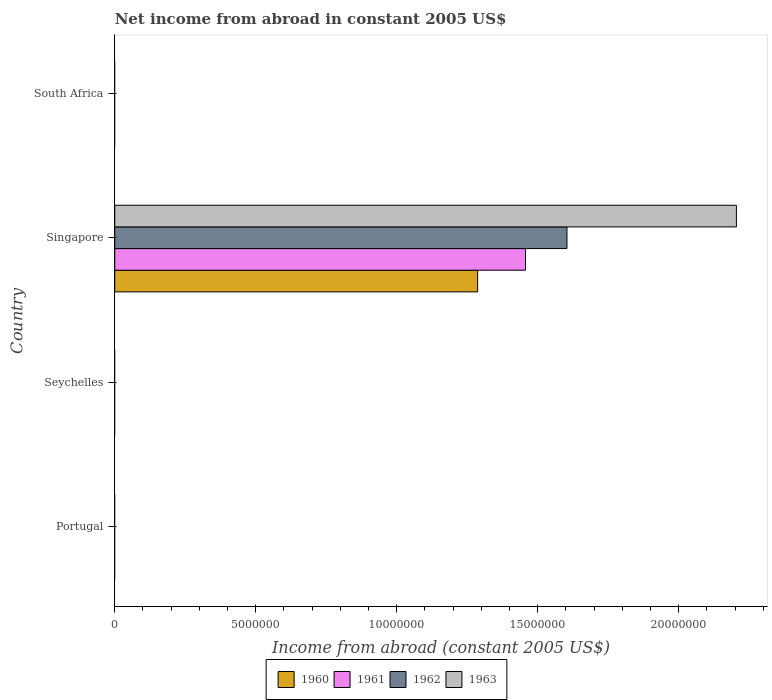How many different coloured bars are there?
Give a very brief answer. 4. Are the number of bars per tick equal to the number of legend labels?
Offer a very short reply. No. How many bars are there on the 2nd tick from the top?
Keep it short and to the point. 4. How many bars are there on the 1st tick from the bottom?
Keep it short and to the point. 0. What is the label of the 2nd group of bars from the top?
Make the answer very short. Singapore. What is the net income from abroad in 1963 in Singapore?
Offer a terse response. 2.20e+07. Across all countries, what is the maximum net income from abroad in 1961?
Make the answer very short. 1.46e+07. In which country was the net income from abroad in 1961 maximum?
Keep it short and to the point. Singapore. What is the total net income from abroad in 1961 in the graph?
Ensure brevity in your answer.  1.46e+07. What is the difference between the net income from abroad in 1961 in South Africa and the net income from abroad in 1960 in Singapore?
Give a very brief answer. -1.29e+07. What is the average net income from abroad in 1963 per country?
Give a very brief answer. 5.51e+06. What is the difference between the net income from abroad in 1963 and net income from abroad in 1960 in Singapore?
Offer a very short reply. 9.18e+06. In how many countries, is the net income from abroad in 1961 greater than 11000000 US$?
Offer a very short reply. 1. What is the difference between the highest and the lowest net income from abroad in 1961?
Make the answer very short. 1.46e+07. In how many countries, is the net income from abroad in 1961 greater than the average net income from abroad in 1961 taken over all countries?
Give a very brief answer. 1. Is it the case that in every country, the sum of the net income from abroad in 1962 and net income from abroad in 1961 is greater than the net income from abroad in 1960?
Make the answer very short. No. How many bars are there?
Your answer should be compact. 4. Are all the bars in the graph horizontal?
Your answer should be very brief. Yes. What is the difference between two consecutive major ticks on the X-axis?
Offer a terse response. 5.00e+06. Are the values on the major ticks of X-axis written in scientific E-notation?
Your response must be concise. No. How many legend labels are there?
Provide a short and direct response. 4. How are the legend labels stacked?
Offer a very short reply. Horizontal. What is the title of the graph?
Your answer should be compact. Net income from abroad in constant 2005 US$. Does "1998" appear as one of the legend labels in the graph?
Your answer should be very brief. No. What is the label or title of the X-axis?
Make the answer very short. Income from abroad (constant 2005 US$). What is the Income from abroad (constant 2005 US$) of 1960 in Portugal?
Your answer should be compact. 0. What is the Income from abroad (constant 2005 US$) in 1962 in Portugal?
Ensure brevity in your answer.  0. What is the Income from abroad (constant 2005 US$) of 1963 in Portugal?
Your answer should be compact. 0. What is the Income from abroad (constant 2005 US$) in 1960 in Seychelles?
Your response must be concise. 0. What is the Income from abroad (constant 2005 US$) in 1961 in Seychelles?
Your answer should be very brief. 0. What is the Income from abroad (constant 2005 US$) in 1963 in Seychelles?
Provide a short and direct response. 0. What is the Income from abroad (constant 2005 US$) of 1960 in Singapore?
Provide a short and direct response. 1.29e+07. What is the Income from abroad (constant 2005 US$) in 1961 in Singapore?
Offer a terse response. 1.46e+07. What is the Income from abroad (constant 2005 US$) of 1962 in Singapore?
Offer a very short reply. 1.60e+07. What is the Income from abroad (constant 2005 US$) of 1963 in Singapore?
Provide a short and direct response. 2.20e+07. What is the Income from abroad (constant 2005 US$) of 1962 in South Africa?
Give a very brief answer. 0. Across all countries, what is the maximum Income from abroad (constant 2005 US$) of 1960?
Provide a short and direct response. 1.29e+07. Across all countries, what is the maximum Income from abroad (constant 2005 US$) of 1961?
Your response must be concise. 1.46e+07. Across all countries, what is the maximum Income from abroad (constant 2005 US$) of 1962?
Offer a terse response. 1.60e+07. Across all countries, what is the maximum Income from abroad (constant 2005 US$) in 1963?
Give a very brief answer. 2.20e+07. Across all countries, what is the minimum Income from abroad (constant 2005 US$) of 1962?
Ensure brevity in your answer.  0. Across all countries, what is the minimum Income from abroad (constant 2005 US$) in 1963?
Offer a terse response. 0. What is the total Income from abroad (constant 2005 US$) of 1960 in the graph?
Offer a very short reply. 1.29e+07. What is the total Income from abroad (constant 2005 US$) in 1961 in the graph?
Provide a short and direct response. 1.46e+07. What is the total Income from abroad (constant 2005 US$) in 1962 in the graph?
Ensure brevity in your answer.  1.60e+07. What is the total Income from abroad (constant 2005 US$) of 1963 in the graph?
Your response must be concise. 2.20e+07. What is the average Income from abroad (constant 2005 US$) of 1960 per country?
Give a very brief answer. 3.22e+06. What is the average Income from abroad (constant 2005 US$) in 1961 per country?
Provide a short and direct response. 3.64e+06. What is the average Income from abroad (constant 2005 US$) of 1962 per country?
Offer a terse response. 4.01e+06. What is the average Income from abroad (constant 2005 US$) in 1963 per country?
Your response must be concise. 5.51e+06. What is the difference between the Income from abroad (constant 2005 US$) of 1960 and Income from abroad (constant 2005 US$) of 1961 in Singapore?
Provide a short and direct response. -1.70e+06. What is the difference between the Income from abroad (constant 2005 US$) of 1960 and Income from abroad (constant 2005 US$) of 1962 in Singapore?
Your response must be concise. -3.17e+06. What is the difference between the Income from abroad (constant 2005 US$) of 1960 and Income from abroad (constant 2005 US$) of 1963 in Singapore?
Your response must be concise. -9.18e+06. What is the difference between the Income from abroad (constant 2005 US$) of 1961 and Income from abroad (constant 2005 US$) of 1962 in Singapore?
Your answer should be compact. -1.47e+06. What is the difference between the Income from abroad (constant 2005 US$) of 1961 and Income from abroad (constant 2005 US$) of 1963 in Singapore?
Provide a short and direct response. -7.48e+06. What is the difference between the Income from abroad (constant 2005 US$) in 1962 and Income from abroad (constant 2005 US$) in 1963 in Singapore?
Offer a very short reply. -6.01e+06. What is the difference between the highest and the lowest Income from abroad (constant 2005 US$) in 1960?
Offer a terse response. 1.29e+07. What is the difference between the highest and the lowest Income from abroad (constant 2005 US$) in 1961?
Make the answer very short. 1.46e+07. What is the difference between the highest and the lowest Income from abroad (constant 2005 US$) in 1962?
Provide a succinct answer. 1.60e+07. What is the difference between the highest and the lowest Income from abroad (constant 2005 US$) in 1963?
Ensure brevity in your answer.  2.20e+07. 